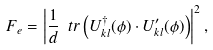Convert formula to latex. <formula><loc_0><loc_0><loc_500><loc_500>F _ { e } = \left | \frac { 1 } { d } \ t r \left ( U ^ { \dagger } _ { k l } ( \phi ) \cdot U ^ { \prime } _ { k l } ( \phi ) \right ) \right | ^ { 2 } ,</formula> 